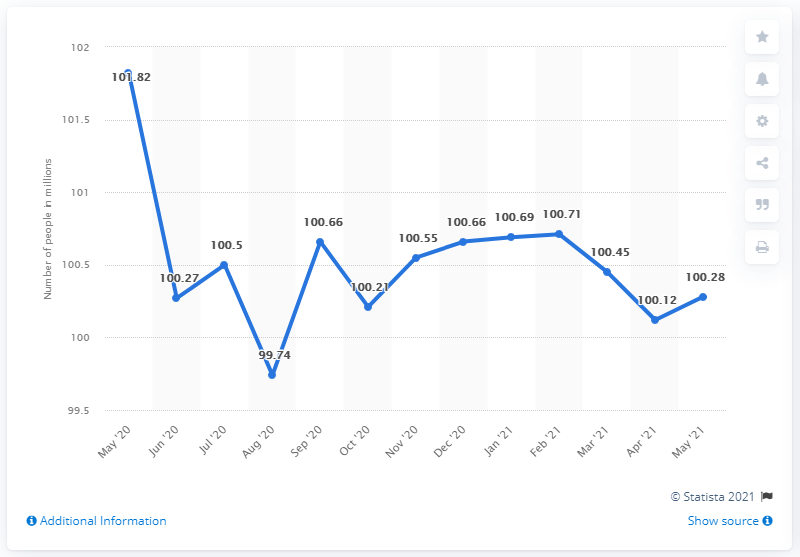How many people were in the inactive labor force in May 2021?
 100.28 